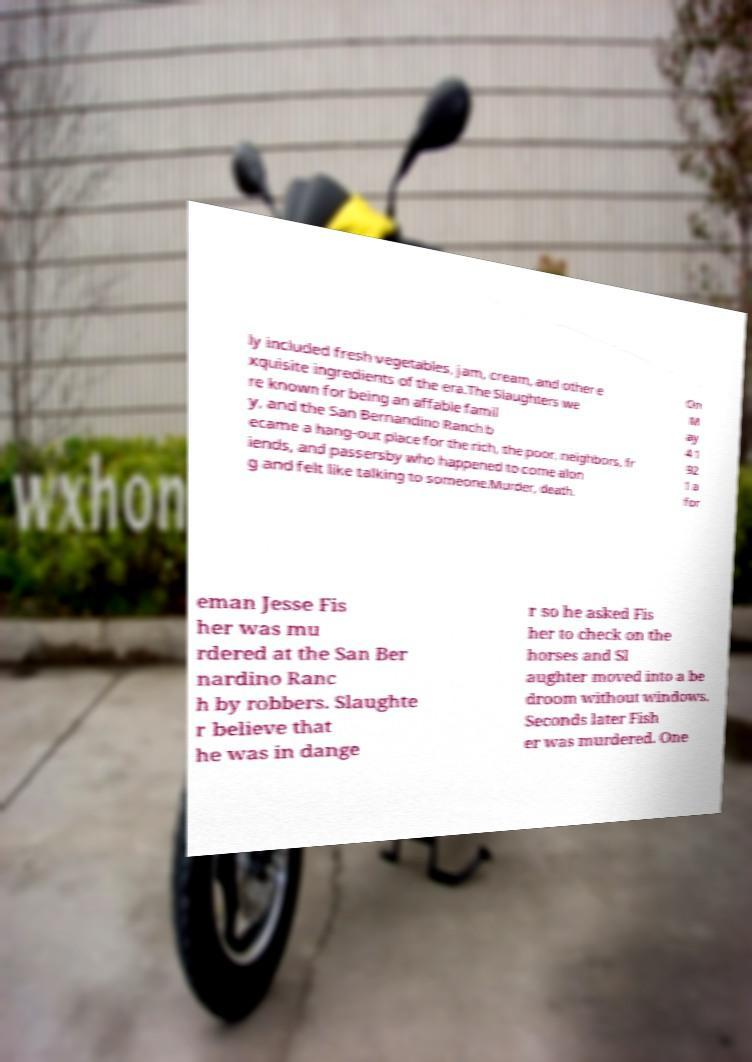What messages or text are displayed in this image? I need them in a readable, typed format. ly included fresh vegetables, jam, cream, and other e xquisite ingredients of the era.The Slaughters we re known for being an affable famil y, and the San Bernandino Ranch b ecame a hang-out place for the rich, the poor, neighbors, fr iends, and passersby who happened to come alon g and felt like talking to someone.Murder, death. On M ay 4 1 92 1 a for eman Jesse Fis her was mu rdered at the San Ber nardino Ranc h by robbers. Slaughte r believe that he was in dange r so he asked Fis her to check on the horses and Sl aughter moved into a be droom without windows. Seconds later Fish er was murdered. One 